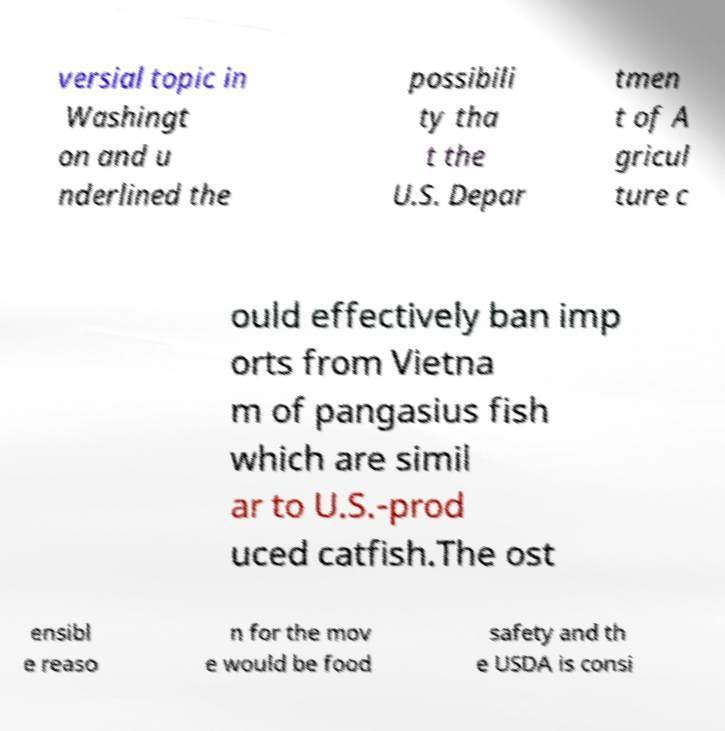What messages or text are displayed in this image? I need them in a readable, typed format. versial topic in Washingt on and u nderlined the possibili ty tha t the U.S. Depar tmen t of A gricul ture c ould effectively ban imp orts from Vietna m of pangasius fish which are simil ar to U.S.-prod uced catfish.The ost ensibl e reaso n for the mov e would be food safety and th e USDA is consi 